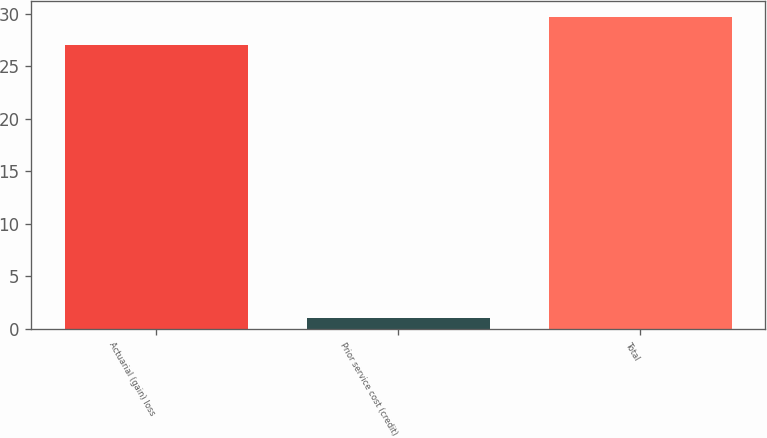<chart> <loc_0><loc_0><loc_500><loc_500><bar_chart><fcel>Actuarial (gain) loss<fcel>Prior service cost (credit)<fcel>Total<nl><fcel>27<fcel>1<fcel>29.7<nl></chart> 